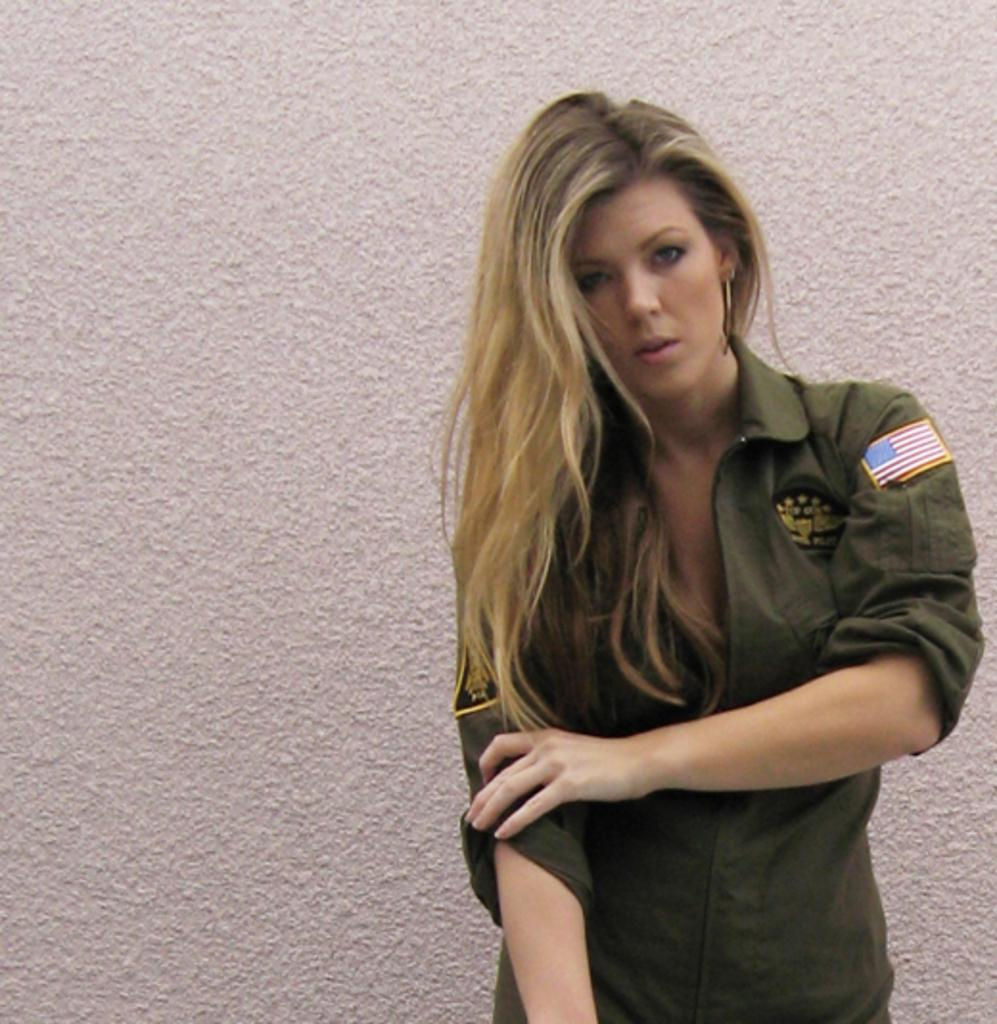What is the main subject of the image? There is a person standing in the image. What can be seen in the background of the image? There is a wall in the background of the image. What type of tank is visible in the image? There is no tank present in the image; it only features a person standing and a wall in the background. 